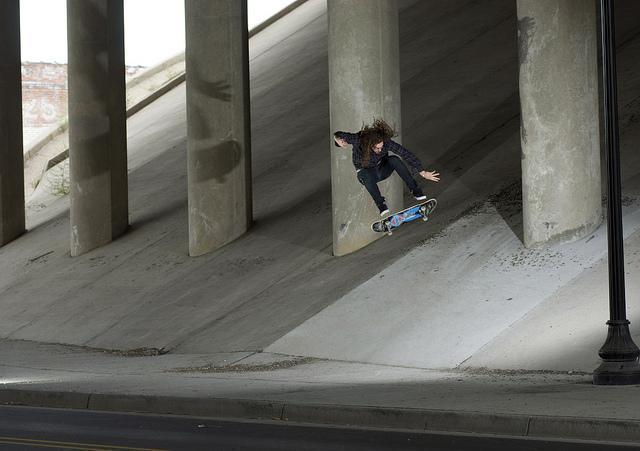How many babies are there?
Give a very brief answer. 0. 